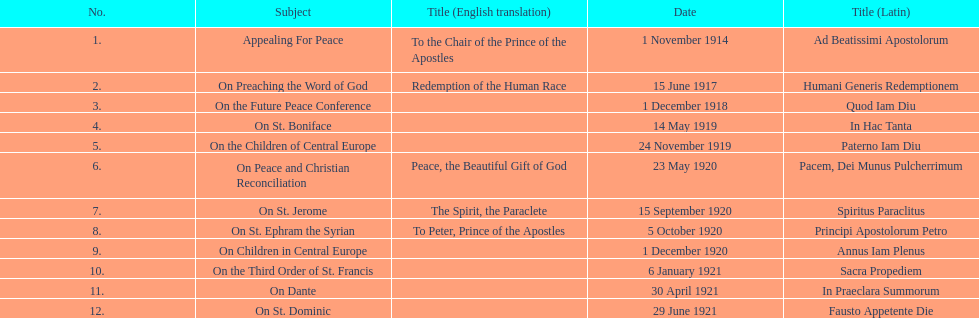How many titles are listed in the table? 12. 